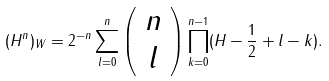Convert formula to latex. <formula><loc_0><loc_0><loc_500><loc_500>( H ^ { n } ) _ { W } = 2 ^ { - n } \sum _ { l = 0 } ^ { n } \left ( \begin{array} { c } n \\ l \end{array} \right ) \prod _ { k = 0 } ^ { n - 1 } ( H - \frac { 1 } { 2 } + l - k ) .</formula> 